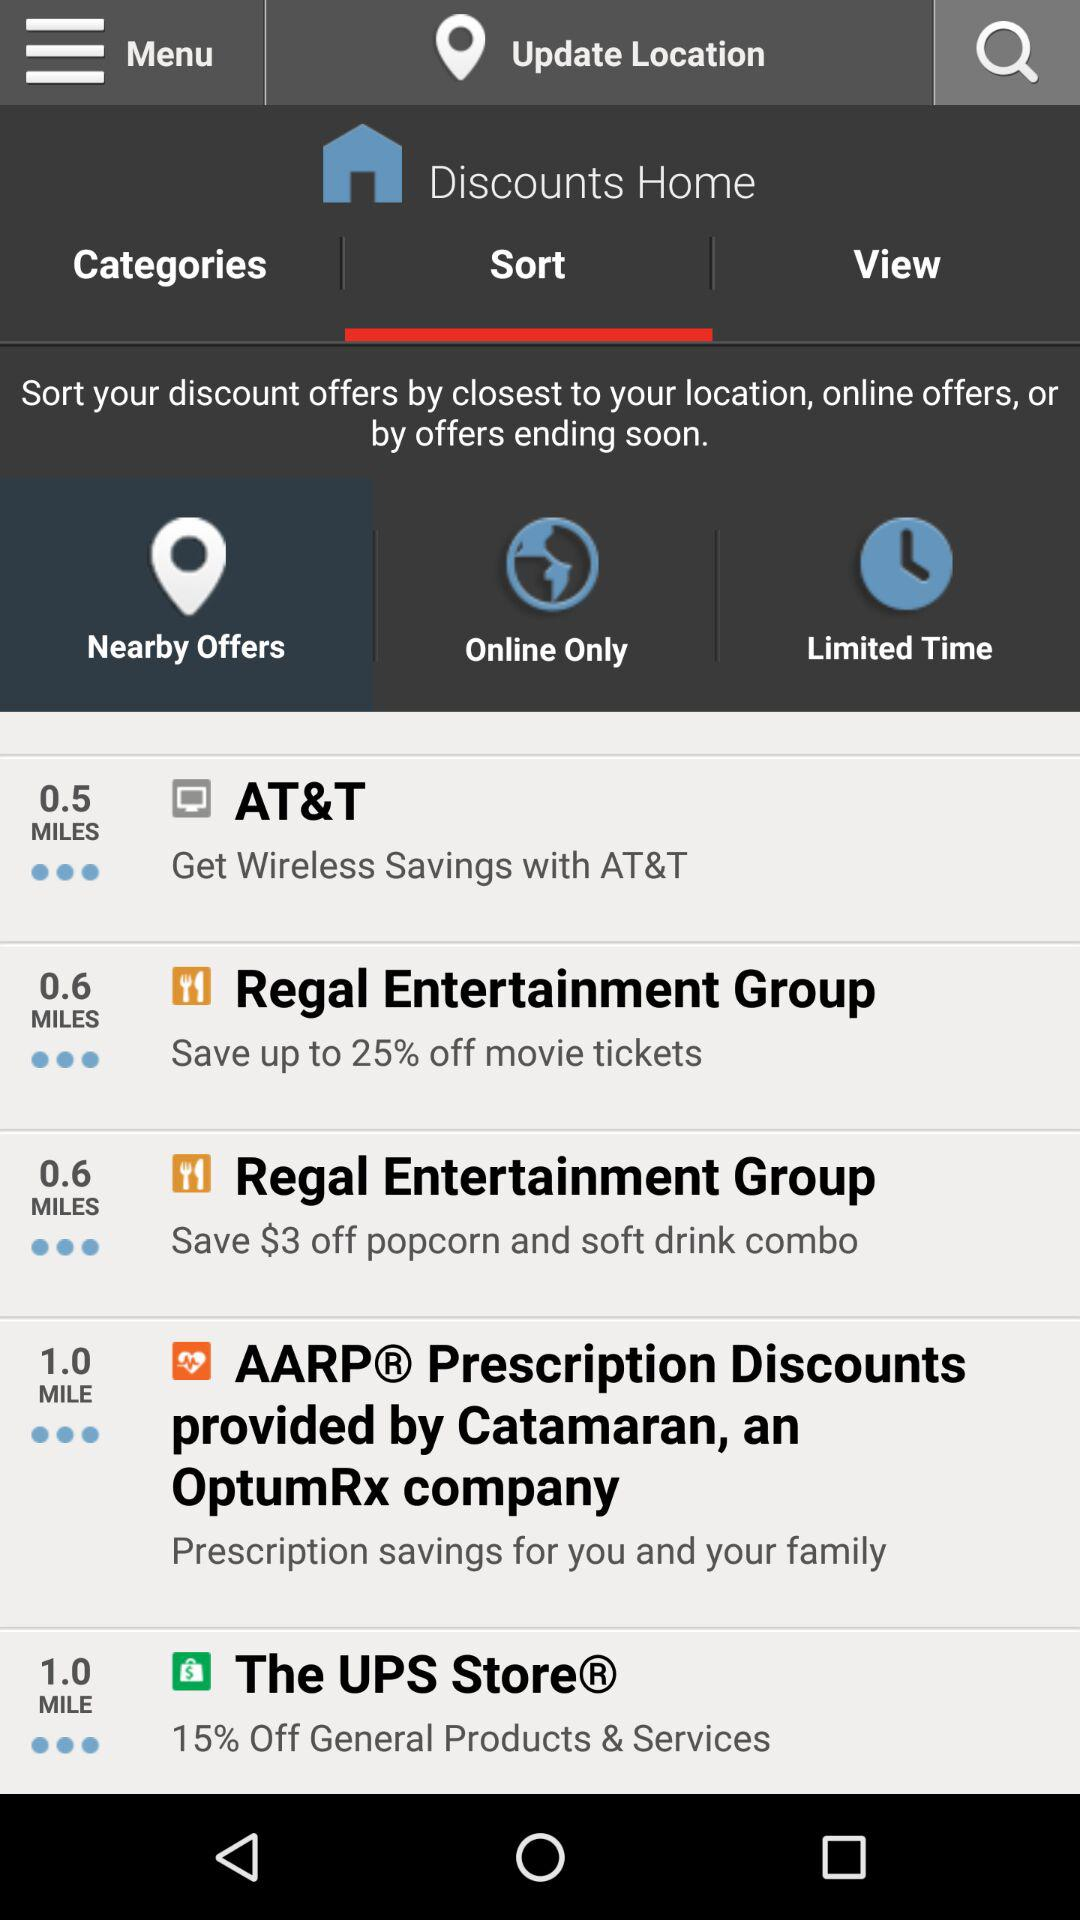How many miles away is "AT&T"? "AT&T" is 0.5 miles away. 